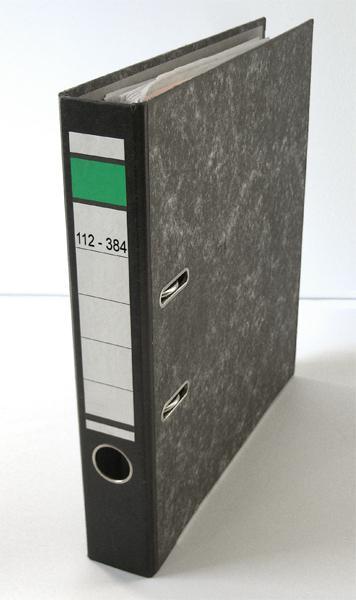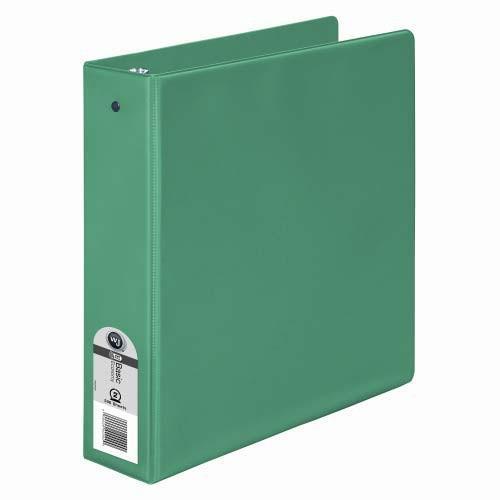The first image is the image on the left, the second image is the image on the right. For the images displayed, is the sentence "Exactly two ring binder notebooks with plastic cover, each a different color, are standing on end, at least one of them empty." factually correct? Answer yes or no. Yes. The first image is the image on the left, the second image is the image on the right. Assess this claim about the two images: "There are two binders in total.". Correct or not? Answer yes or no. Yes. 